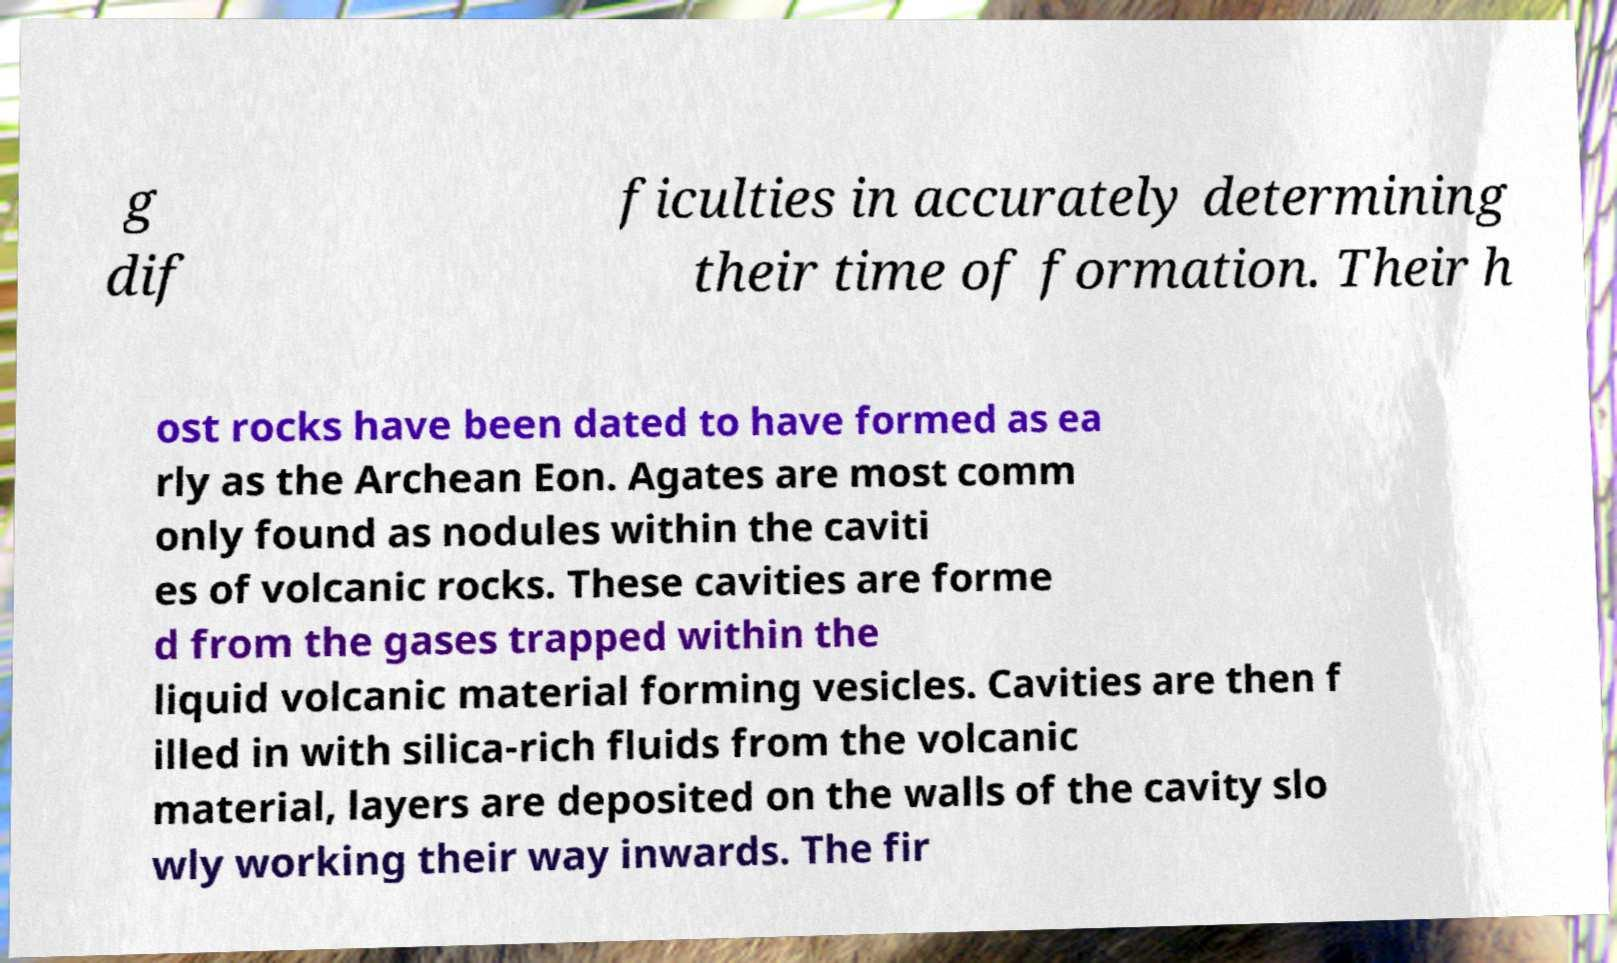Could you assist in decoding the text presented in this image and type it out clearly? g dif ficulties in accurately determining their time of formation. Their h ost rocks have been dated to have formed as ea rly as the Archean Eon. Agates are most comm only found as nodules within the caviti es of volcanic rocks. These cavities are forme d from the gases trapped within the liquid volcanic material forming vesicles. Cavities are then f illed in with silica-rich fluids from the volcanic material, layers are deposited on the walls of the cavity slo wly working their way inwards. The fir 